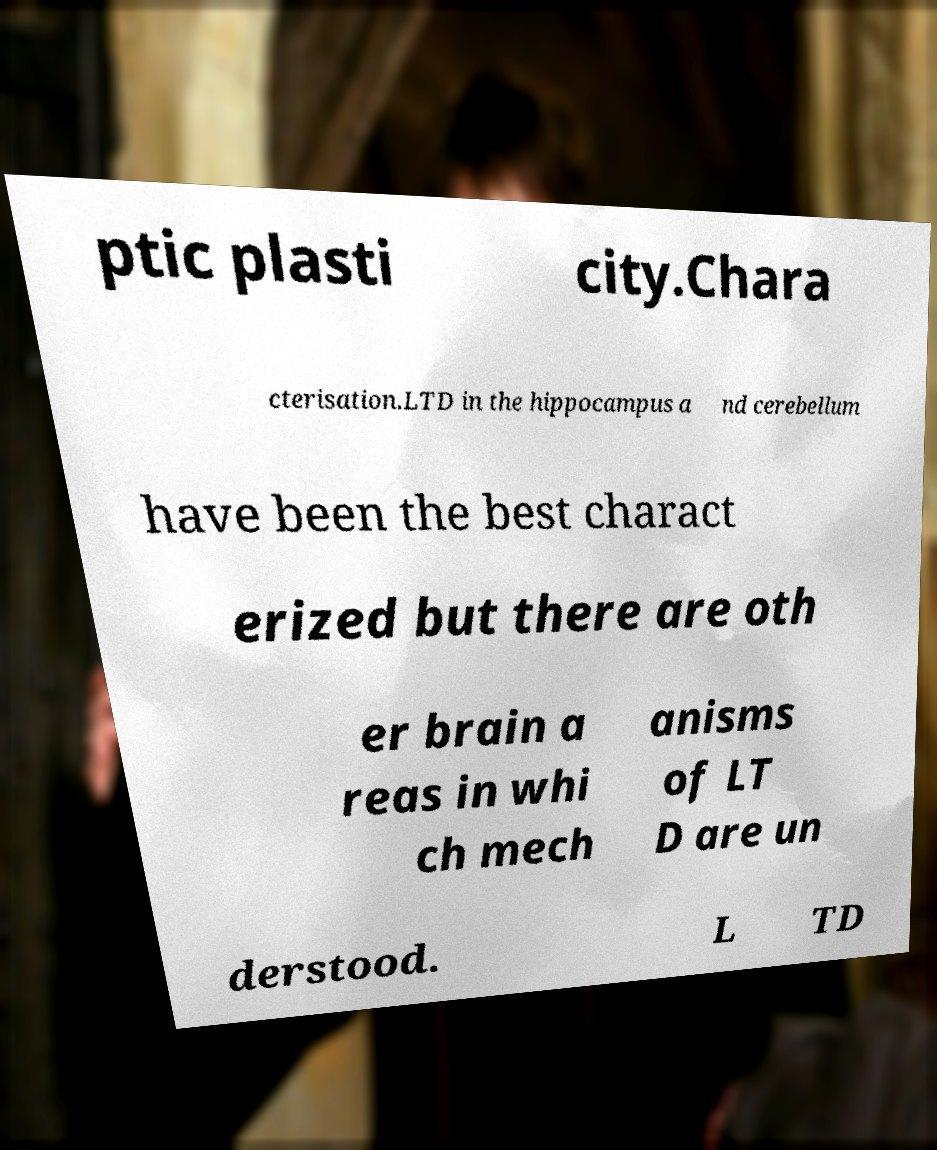Could you assist in decoding the text presented in this image and type it out clearly? ptic plasti city.Chara cterisation.LTD in the hippocampus a nd cerebellum have been the best charact erized but there are oth er brain a reas in whi ch mech anisms of LT D are un derstood. L TD 